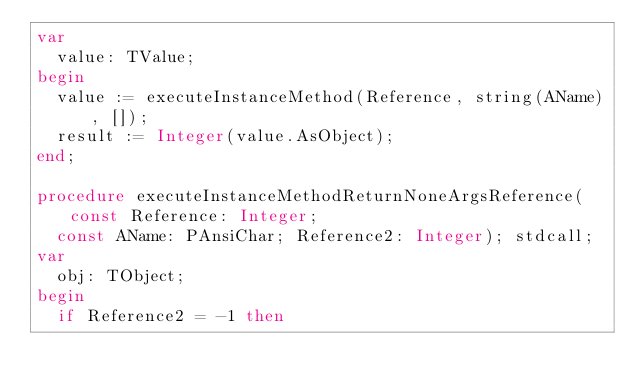<code> <loc_0><loc_0><loc_500><loc_500><_Pascal_>var
  value: TValue;
begin
  value := executeInstanceMethod(Reference, string(AName), []);
  result := Integer(value.AsObject);
end;

procedure executeInstanceMethodReturnNoneArgsReference(const Reference: Integer;
  const AName: PAnsiChar; Reference2: Integer); stdcall;
var
  obj: TObject;
begin
  if Reference2 = -1 then</code> 